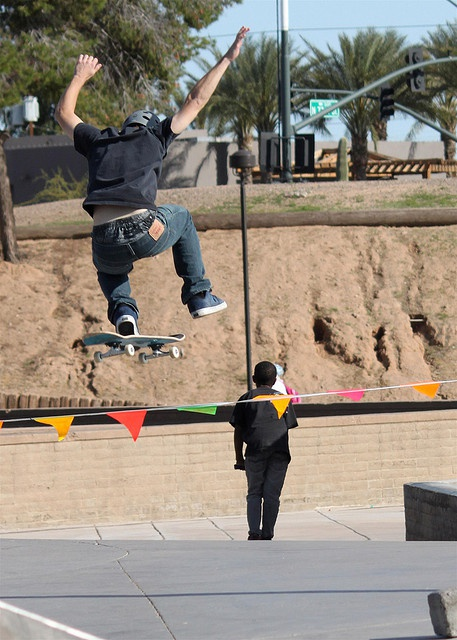Describe the objects in this image and their specific colors. I can see people in black, gray, and tan tones, people in black, gray, and lightgray tones, skateboard in black, gray, blue, and darkgray tones, bench in black, maroon, and gray tones, and bench in black, tan, and gray tones in this image. 